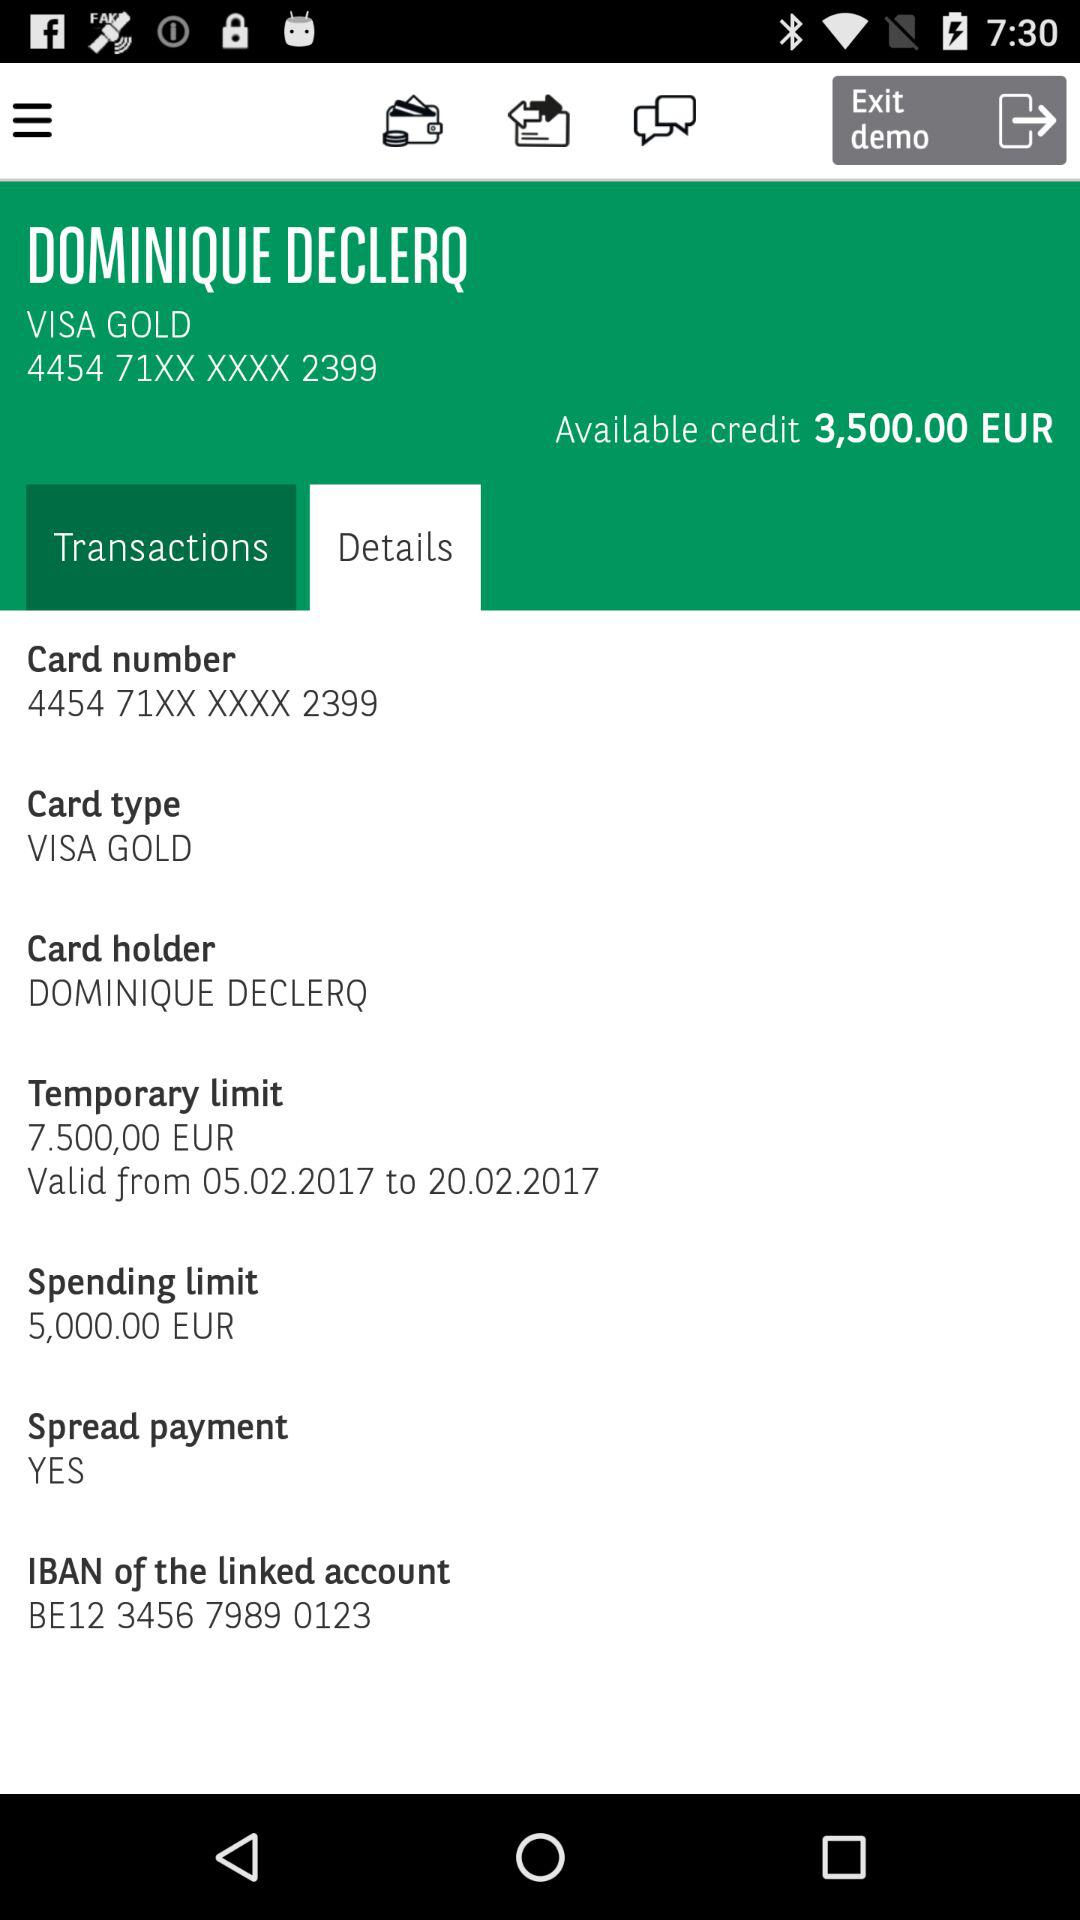What is the name of the card holder? The name of the card holder is Dominique Declerq. 